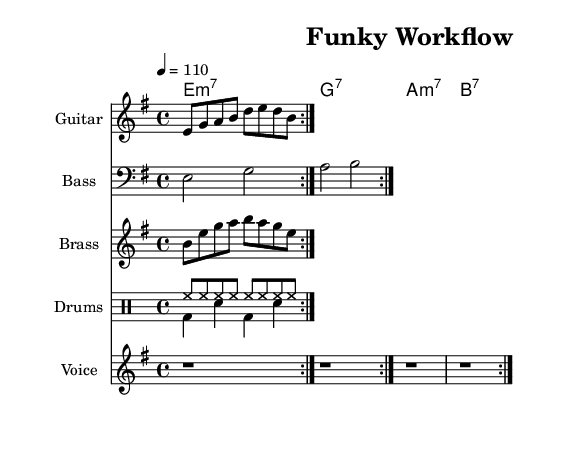What is the key signature of this music? The key signature is E minor, which has one sharp (F#). It can be identified by looking at the clef and the specific symbols placed at the beginning of the staff before the measures.
Answer: E minor What is the time signature of the piece? The time signature is 4/4, which indicates there are four beats in a measure and a quarter note receives one beat. It can be seen at the beginning of the staff before the notes begin.
Answer: 4/4 What is the tempo indicated in the score? The tempo is marked as 4 = 110, which means there should be 110 beats per minute. This is indicated at the beginning of the score, providing a tempo marking for the performance.
Answer: 110 How many measures are repeated in the electric guitar section? The electric guitar section features two measures that are repeated, as indicated by the repeat volta symbols and the notation structure of the passage.
Answer: 2 What chord progression is used throughout the piece? The chord progression is E minor 7, G 7, A minor 7, and B 7, shown in the ChordNames section. These are labeled with the corresponding chord names in standard music notation format, which creates the harmonic framework for the piece.
Answer: E minor 7, G 7, A minor 7, B 7 What is the main lyrical theme of the verses? The main lyrical theme of the verses focuses on data flow and optimizing tasks, as indicated by the words in the verseWords section. The lyrics highlight the importance of efficiency in handling tasks.
Answer: Data flows, algorithms run What unique aspects of funk music are represented in the rhythms? The unique aspects include syncopation and the repeated drum patterns, which create a cohesive funky vibe and encourage movement. The combination of drumming styles and the brass riff adds to the overall funk style.
Answer: Syncopation and repeated patterns 